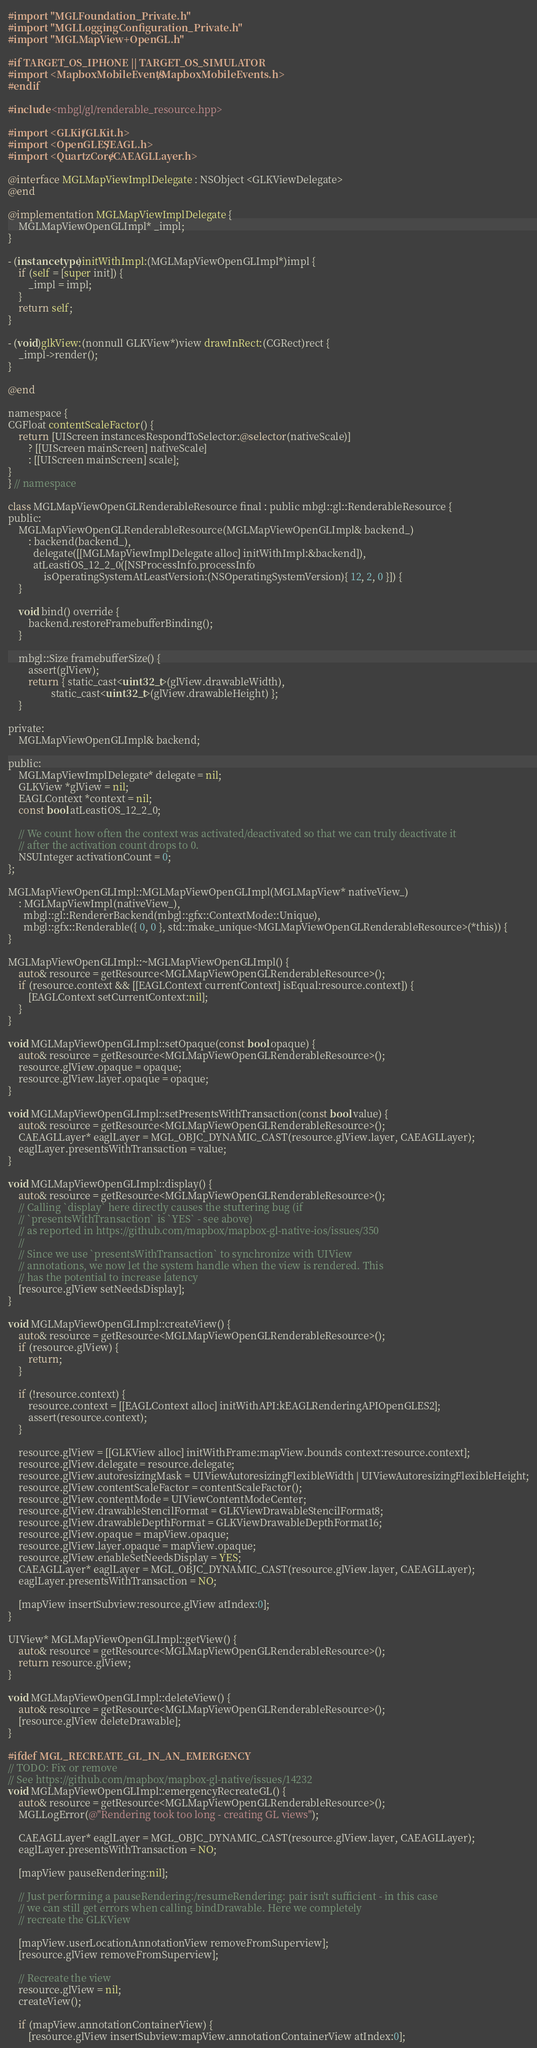Convert code to text. <code><loc_0><loc_0><loc_500><loc_500><_ObjectiveC_>#import "MGLFoundation_Private.h"
#import "MGLLoggingConfiguration_Private.h"
#import "MGLMapView+OpenGL.h"

#if TARGET_OS_IPHONE || TARGET_OS_SIMULATOR
#import <MapboxMobileEvents/MapboxMobileEvents.h>
#endif

#include <mbgl/gl/renderable_resource.hpp>

#import <GLKit/GLKit.h>
#import <OpenGLES/EAGL.h>
#import <QuartzCore/CAEAGLLayer.h>

@interface MGLMapViewImplDelegate : NSObject <GLKViewDelegate>
@end

@implementation MGLMapViewImplDelegate {
    MGLMapViewOpenGLImpl* _impl;
}

- (instancetype)initWithImpl:(MGLMapViewOpenGLImpl*)impl {
    if (self = [super init]) {
        _impl = impl;
    }
    return self;
}

- (void)glkView:(nonnull GLKView*)view drawInRect:(CGRect)rect {
    _impl->render();
}

@end

namespace {
CGFloat contentScaleFactor() {
    return [UIScreen instancesRespondToSelector:@selector(nativeScale)]
        ? [[UIScreen mainScreen] nativeScale]
        : [[UIScreen mainScreen] scale];
}
} // namespace

class MGLMapViewOpenGLRenderableResource final : public mbgl::gl::RenderableResource {
public:
    MGLMapViewOpenGLRenderableResource(MGLMapViewOpenGLImpl& backend_)
        : backend(backend_),
          delegate([[MGLMapViewImplDelegate alloc] initWithImpl:&backend]),
          atLeastiOS_12_2_0([NSProcessInfo.processInfo
              isOperatingSystemAtLeastVersion:(NSOperatingSystemVersion){ 12, 2, 0 }]) {
    }

    void bind() override {
        backend.restoreFramebufferBinding();
    }

    mbgl::Size framebufferSize() {
        assert(glView);
        return { static_cast<uint32_t>(glView.drawableWidth),
                 static_cast<uint32_t>(glView.drawableHeight) };
    }

private:
    MGLMapViewOpenGLImpl& backend;

public:
    MGLMapViewImplDelegate* delegate = nil;
    GLKView *glView = nil;
    EAGLContext *context = nil;
    const bool atLeastiOS_12_2_0;

    // We count how often the context was activated/deactivated so that we can truly deactivate it
    // after the activation count drops to 0.
    NSUInteger activationCount = 0;
};

MGLMapViewOpenGLImpl::MGLMapViewOpenGLImpl(MGLMapView* nativeView_)
    : MGLMapViewImpl(nativeView_),
      mbgl::gl::RendererBackend(mbgl::gfx::ContextMode::Unique),
      mbgl::gfx::Renderable({ 0, 0 }, std::make_unique<MGLMapViewOpenGLRenderableResource>(*this)) {
}

MGLMapViewOpenGLImpl::~MGLMapViewOpenGLImpl() {
    auto& resource = getResource<MGLMapViewOpenGLRenderableResource>();
    if (resource.context && [[EAGLContext currentContext] isEqual:resource.context]) {
        [EAGLContext setCurrentContext:nil];
    }
}

void MGLMapViewOpenGLImpl::setOpaque(const bool opaque) {
    auto& resource = getResource<MGLMapViewOpenGLRenderableResource>();
    resource.glView.opaque = opaque;
    resource.glView.layer.opaque = opaque;
}

void MGLMapViewOpenGLImpl::setPresentsWithTransaction(const bool value) {
    auto& resource = getResource<MGLMapViewOpenGLRenderableResource>();
    CAEAGLLayer* eaglLayer = MGL_OBJC_DYNAMIC_CAST(resource.glView.layer, CAEAGLLayer);
    eaglLayer.presentsWithTransaction = value;
}

void MGLMapViewOpenGLImpl::display() {
    auto& resource = getResource<MGLMapViewOpenGLRenderableResource>();
    // Calling `display` here directly causes the stuttering bug (if
    // `presentsWithTransaction` is `YES` - see above)
    // as reported in https://github.com/mapbox/mapbox-gl-native-ios/issues/350
    //
    // Since we use `presentsWithTransaction` to synchronize with UIView
    // annotations, we now let the system handle when the view is rendered. This
    // has the potential to increase latency
    [resource.glView setNeedsDisplay];
}

void MGLMapViewOpenGLImpl::createView() {
    auto& resource = getResource<MGLMapViewOpenGLRenderableResource>();
    if (resource.glView) {
        return;
    }

    if (!resource.context) {
        resource.context = [[EAGLContext alloc] initWithAPI:kEAGLRenderingAPIOpenGLES2];
        assert(resource.context);
    }

    resource.glView = [[GLKView alloc] initWithFrame:mapView.bounds context:resource.context];
    resource.glView.delegate = resource.delegate;
    resource.glView.autoresizingMask = UIViewAutoresizingFlexibleWidth | UIViewAutoresizingFlexibleHeight;
    resource.glView.contentScaleFactor = contentScaleFactor();
    resource.glView.contentMode = UIViewContentModeCenter;
    resource.glView.drawableStencilFormat = GLKViewDrawableStencilFormat8;
    resource.glView.drawableDepthFormat = GLKViewDrawableDepthFormat16;
    resource.glView.opaque = mapView.opaque;
    resource.glView.layer.opaque = mapView.opaque;
    resource.glView.enableSetNeedsDisplay = YES;
    CAEAGLLayer* eaglLayer = MGL_OBJC_DYNAMIC_CAST(resource.glView.layer, CAEAGLLayer);
    eaglLayer.presentsWithTransaction = NO;

    [mapView insertSubview:resource.glView atIndex:0];
}

UIView* MGLMapViewOpenGLImpl::getView() {
    auto& resource = getResource<MGLMapViewOpenGLRenderableResource>();
    return resource.glView;
}

void MGLMapViewOpenGLImpl::deleteView() {
    auto& resource = getResource<MGLMapViewOpenGLRenderableResource>();
    [resource.glView deleteDrawable];
}

#ifdef MGL_RECREATE_GL_IN_AN_EMERGENCY
// TODO: Fix or remove
// See https://github.com/mapbox/mapbox-gl-native/issues/14232
void MGLMapViewOpenGLImpl::emergencyRecreateGL() {
    auto& resource = getResource<MGLMapViewOpenGLRenderableResource>();
    MGLLogError(@"Rendering took too long - creating GL views");

    CAEAGLLayer* eaglLayer = MGL_OBJC_DYNAMIC_CAST(resource.glView.layer, CAEAGLLayer);
    eaglLayer.presentsWithTransaction = NO;

    [mapView pauseRendering:nil];

    // Just performing a pauseRendering:/resumeRendering: pair isn't sufficient - in this case
    // we can still get errors when calling bindDrawable. Here we completely
    // recreate the GLKView

    [mapView.userLocationAnnotationView removeFromSuperview];
    [resource.glView removeFromSuperview];

    // Recreate the view
    resource.glView = nil;
    createView();

    if (mapView.annotationContainerView) {
        [resource.glView insertSubview:mapView.annotationContainerView atIndex:0];</code> 